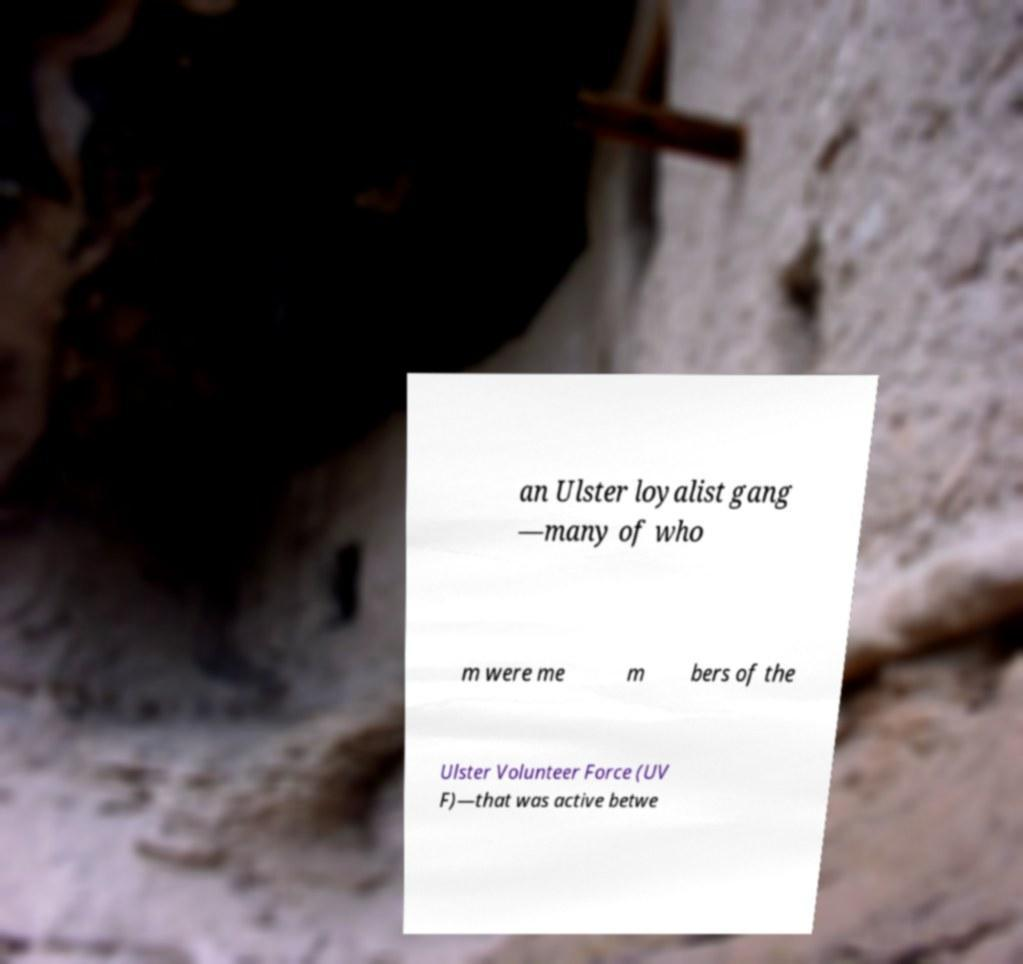Can you read and provide the text displayed in the image?This photo seems to have some interesting text. Can you extract and type it out for me? an Ulster loyalist gang —many of who m were me m bers of the Ulster Volunteer Force (UV F)—that was active betwe 